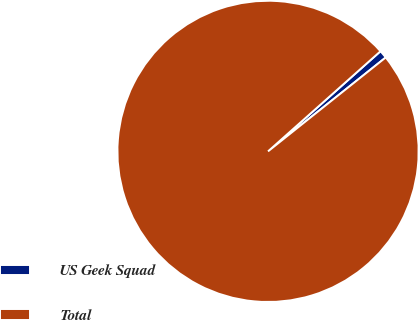<chart> <loc_0><loc_0><loc_500><loc_500><pie_chart><fcel>US Geek Squad<fcel>Total<nl><fcel>0.86%<fcel>99.14%<nl></chart> 